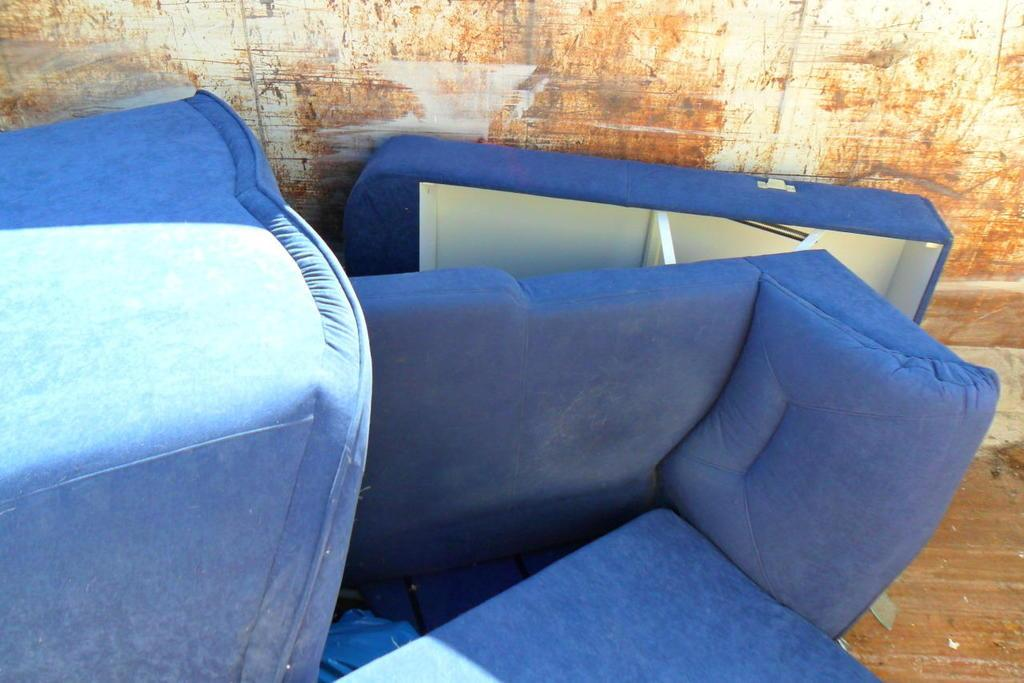What can be seen in the background of the image? There is a rusted wall in the background of the image. What type of furniture is present in the image? There are couches in the image. What color are the couches? The couches are blue in color. Is there a woman sitting on one of the blue couches in the image? There is no woman present in the image; only the rusted wall and blue couches can be seen. What type of appliance is visible on the blue couches in the image? There are no appliances visible on the blue couches in the image. 